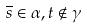Convert formula to latex. <formula><loc_0><loc_0><loc_500><loc_500>\overline { s } \in \alpha , t \notin \gamma</formula> 